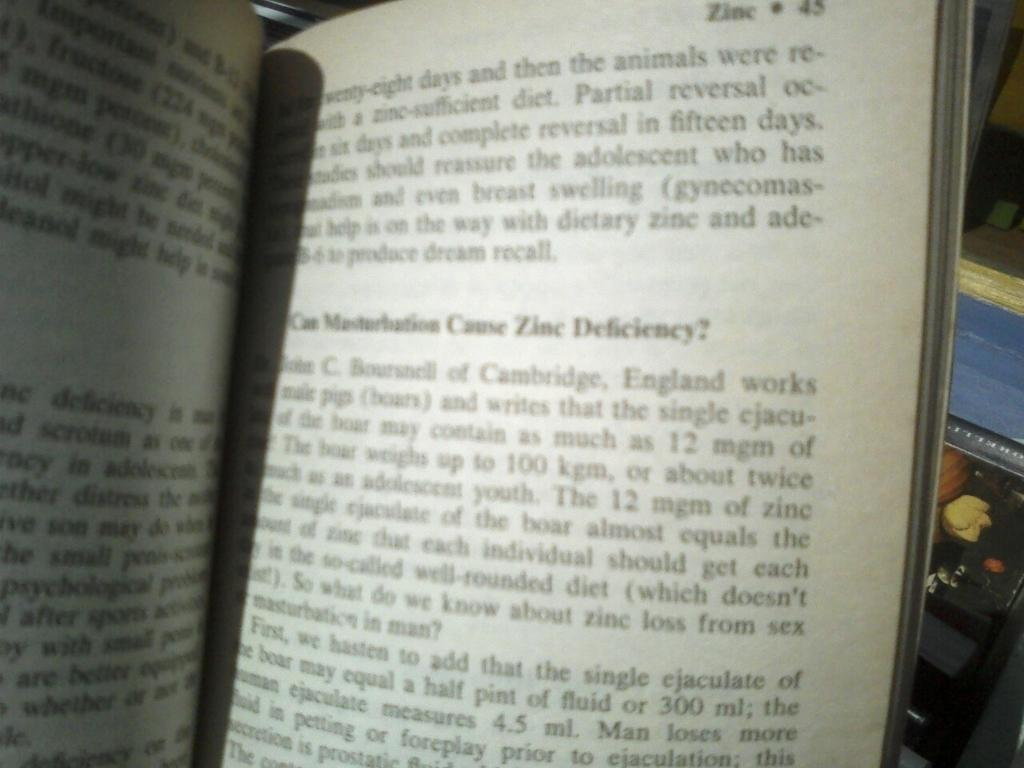<image>
Share a concise interpretation of the image provided. A book is open to a page where is discusses a certain situation that could cause a zinc deficiency. 